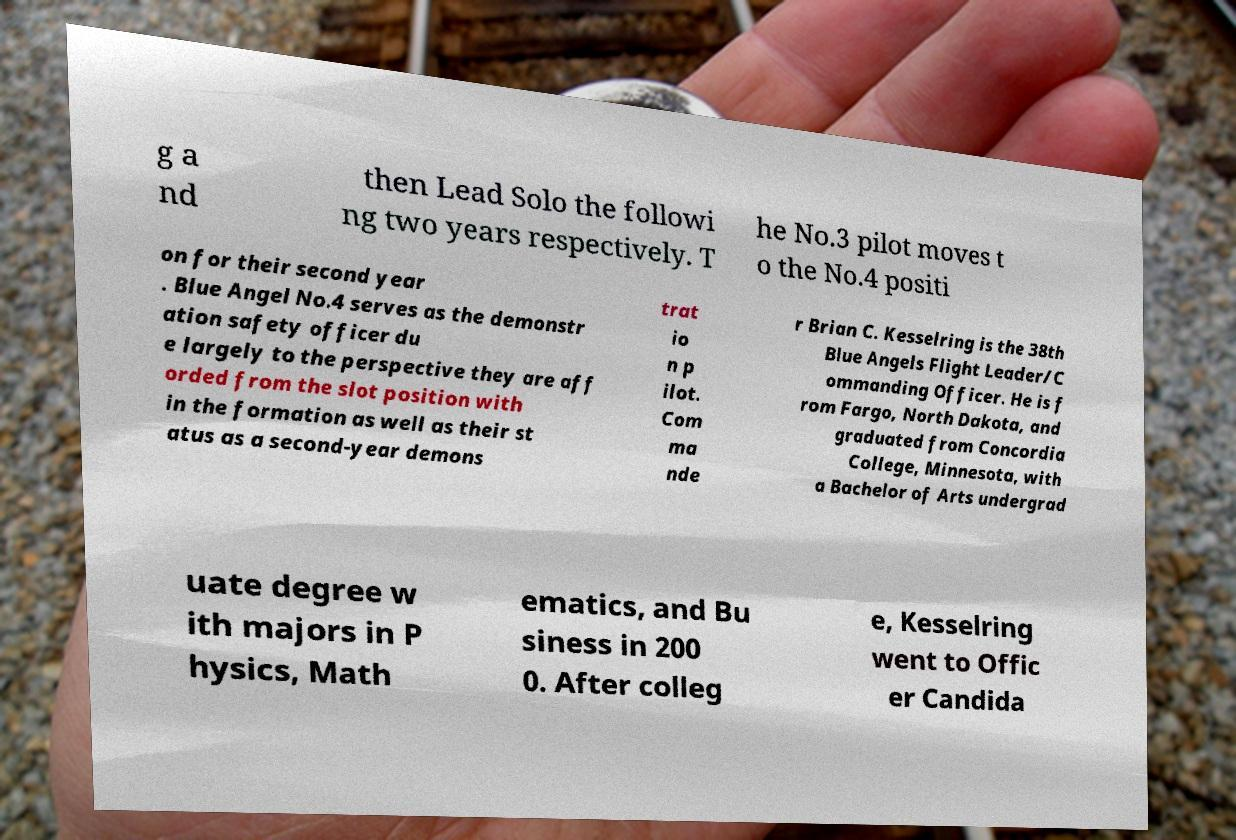What messages or text are displayed in this image? I need them in a readable, typed format. g a nd then Lead Solo the followi ng two years respectively. T he No.3 pilot moves t o the No.4 positi on for their second year . Blue Angel No.4 serves as the demonstr ation safety officer du e largely to the perspective they are aff orded from the slot position with in the formation as well as their st atus as a second-year demons trat io n p ilot. Com ma nde r Brian C. Kesselring is the 38th Blue Angels Flight Leader/C ommanding Officer. He is f rom Fargo, North Dakota, and graduated from Concordia College, Minnesota, with a Bachelor of Arts undergrad uate degree w ith majors in P hysics, Math ematics, and Bu siness in 200 0. After colleg e, Kesselring went to Offic er Candida 